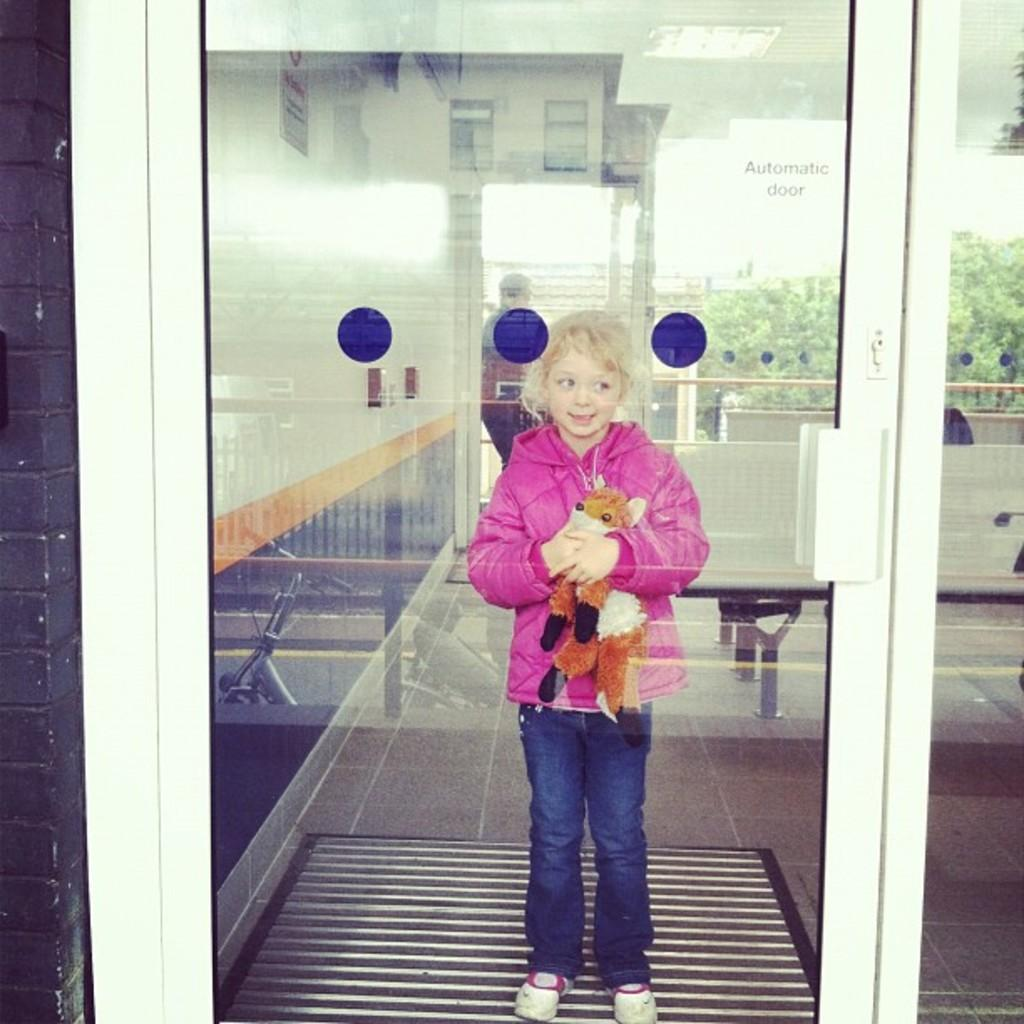Who is present in the image? There is a girl in the image. What is the girl's position in relation to the glass door? The girl is standing inside a glass door. What can be seen in the background of the image? There are chairs, fencing, and trees in the background of the image. What is the color of the wall on the left side of the image? There is a black wall on the left side of the image. What type of rose is the girl holding in the image? There is no rose present in the image; the girl is standing inside a glass door. Can you tell me how many chess pieces are on the floor in the image? There is no chessboard or chess pieces visible in the image. 